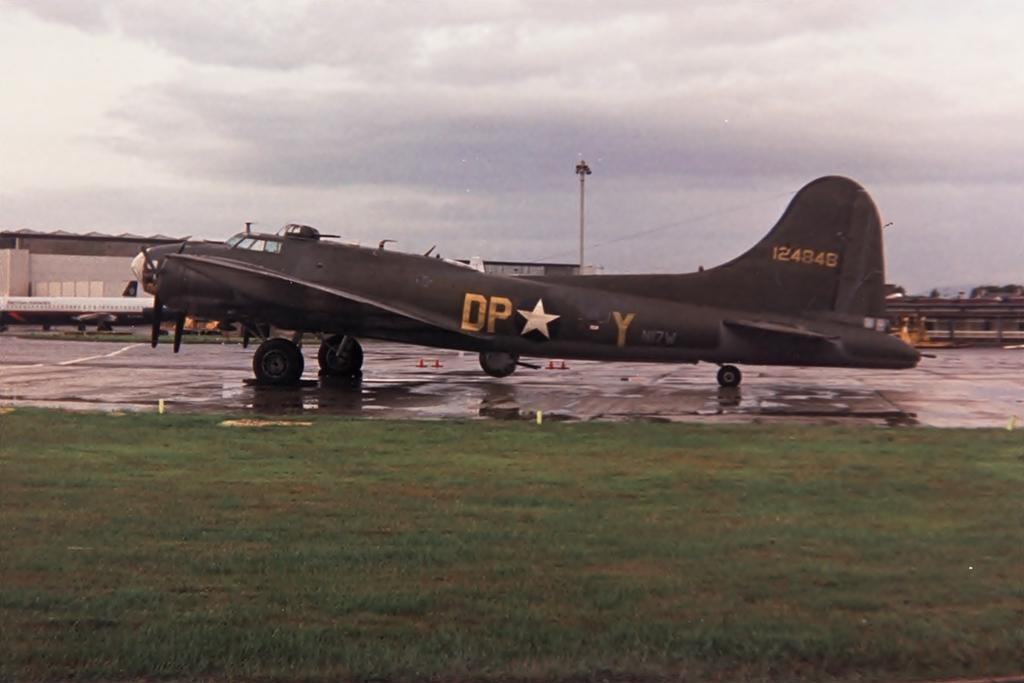<image>
Relay a brief, clear account of the picture shown. old us army dp- y plane sits on the runway 